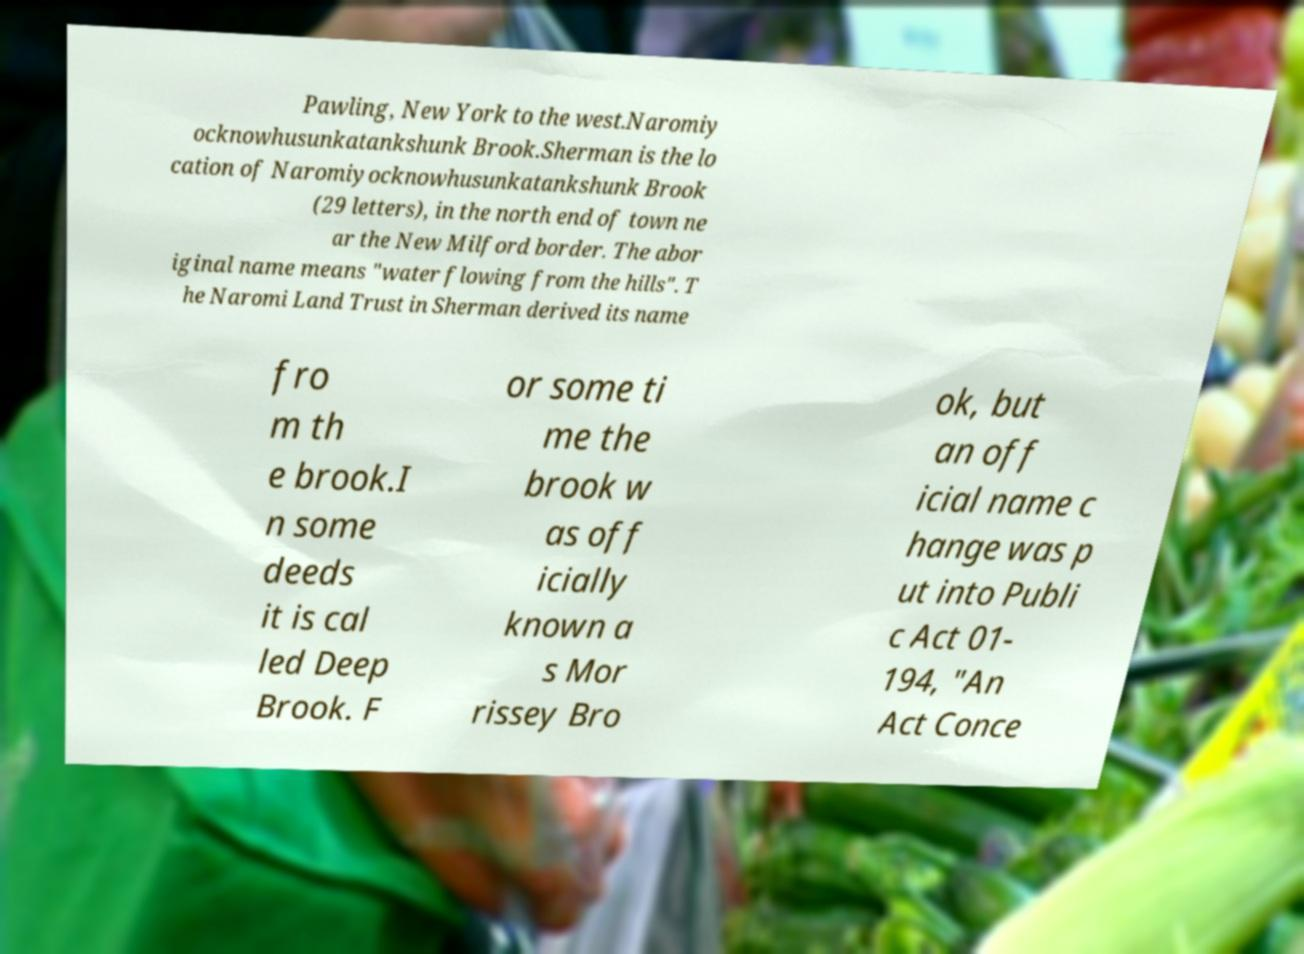Could you extract and type out the text from this image? Pawling, New York to the west.Naromiy ocknowhusunkatankshunk Brook.Sherman is the lo cation of Naromiyocknowhusunkatankshunk Brook (29 letters), in the north end of town ne ar the New Milford border. The abor iginal name means "water flowing from the hills". T he Naromi Land Trust in Sherman derived its name fro m th e brook.I n some deeds it is cal led Deep Brook. F or some ti me the brook w as off icially known a s Mor rissey Bro ok, but an off icial name c hange was p ut into Publi c Act 01- 194, "An Act Conce 